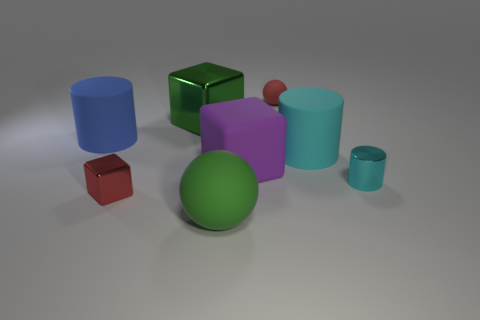Subtract all cyan cubes. Subtract all gray cylinders. How many cubes are left? 3 Add 1 small red matte spheres. How many objects exist? 9 Subtract all cylinders. How many objects are left? 5 Subtract 0 cyan spheres. How many objects are left? 8 Subtract all big yellow matte spheres. Subtract all green metal blocks. How many objects are left? 7 Add 8 small red rubber objects. How many small red rubber objects are left? 9 Add 3 tiny brown rubber things. How many tiny brown rubber things exist? 3 